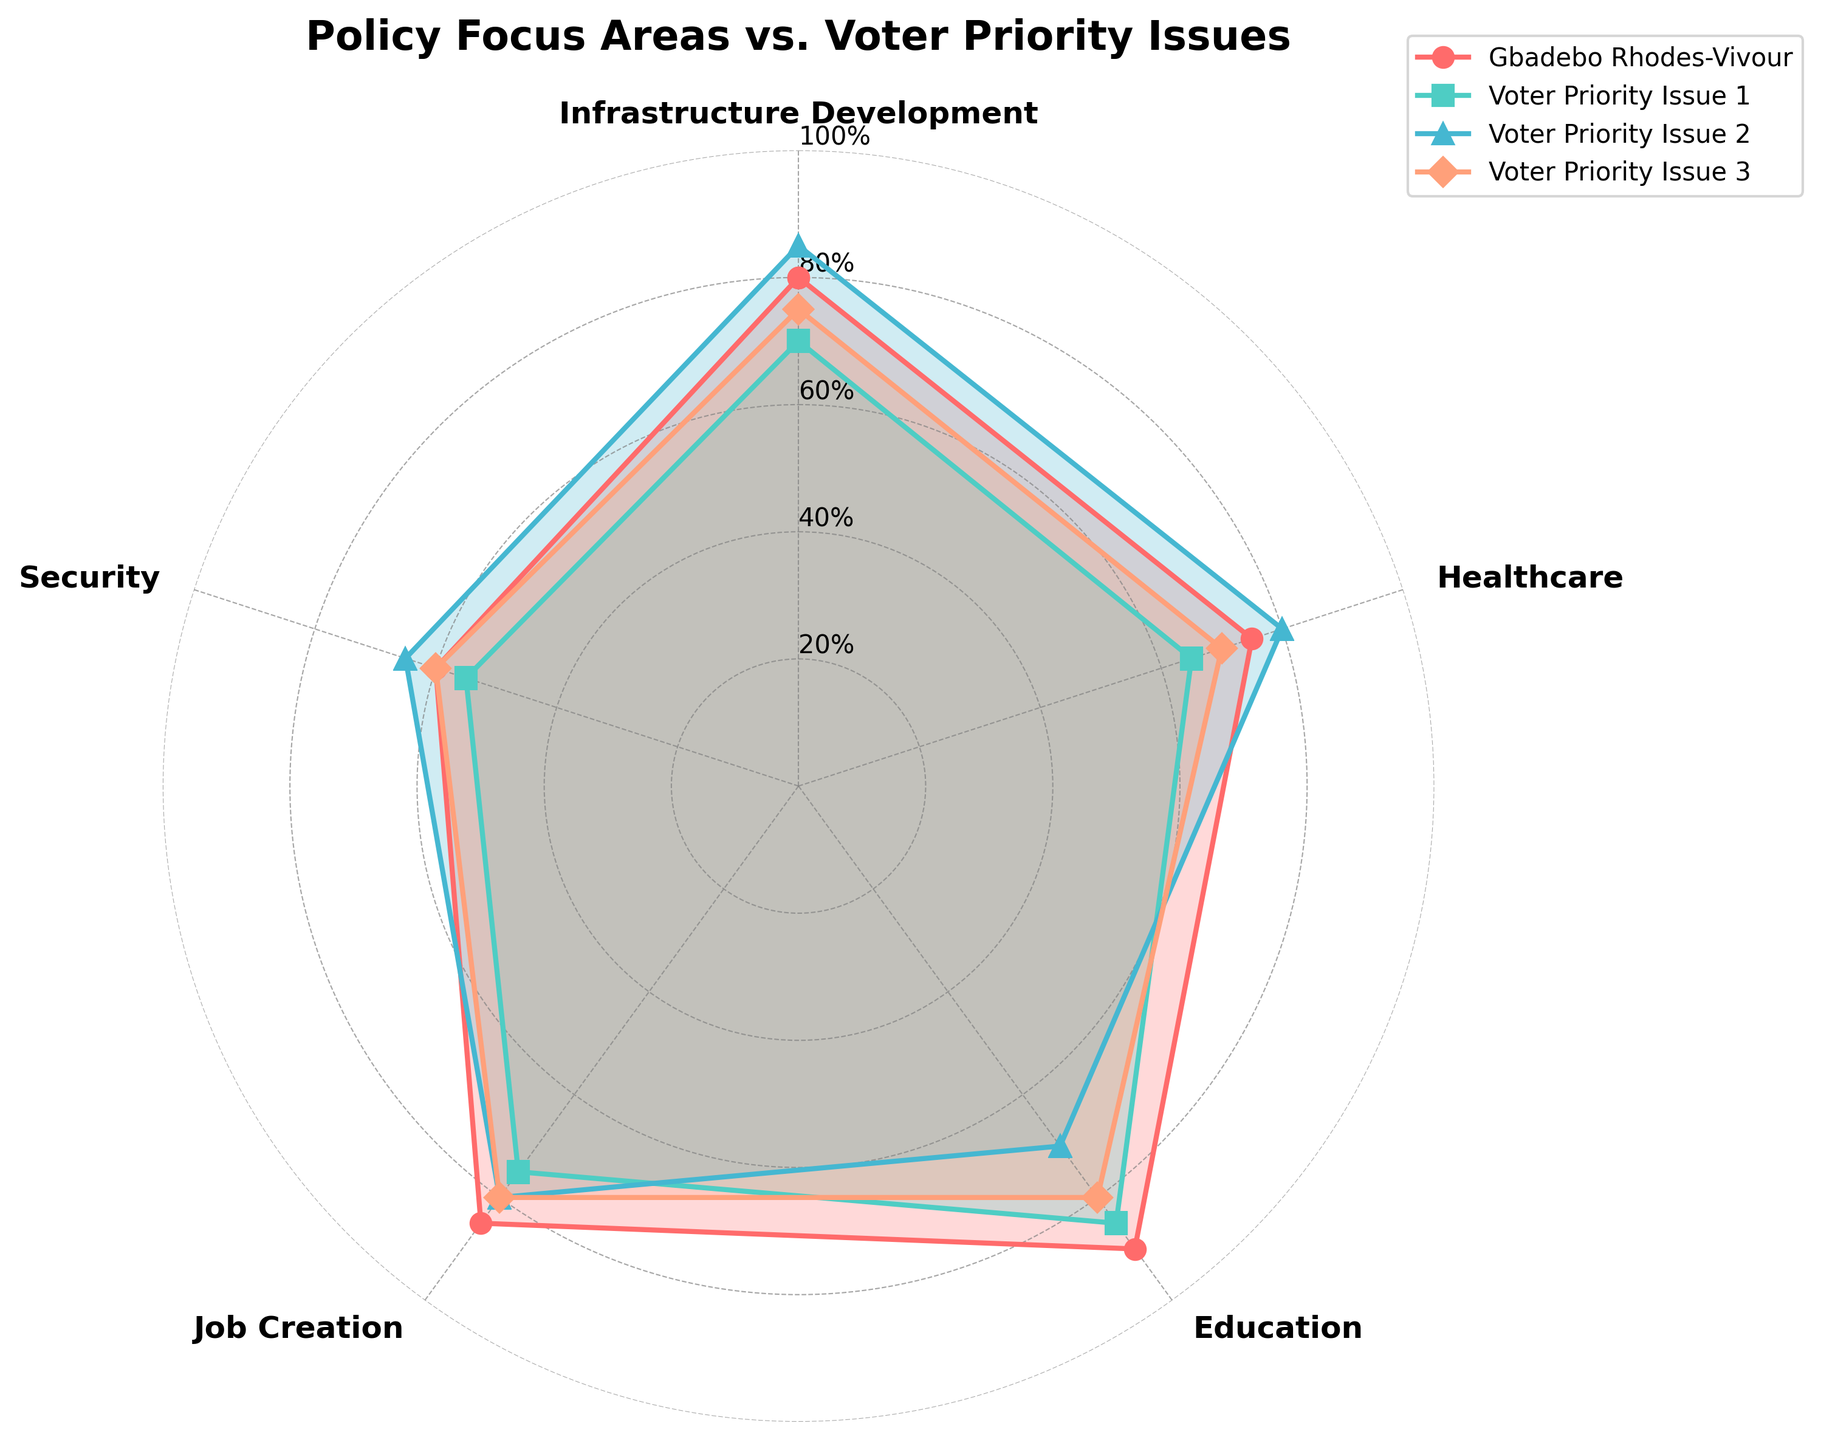What's the title of the figure? The title is usually at the top of the figure, and it provides an overview of what the chart represents. By looking directly at the top of the figure, we can read the title.
Answer: Policy Focus Areas vs. Voter Priority Issues Which policy focus area does Gbadebo Rhodes-Vivour prioritize the most? In the radar chart, Gbadebo Rhodes-Vivour's priorities are indicated by one of the colored lines. The highest value will represent the area of highest priority.
Answer: Education Which group has the highest value in the Security category? By comparing the values of the different colored lines at the Security point on the chart, we can see which group reaches the highest on the Security axis.
Answer: Voter Priority Issue 2 What is the difference in the Job Creation priority between Gbadebo Rhodes-Vivour and Voter Priority Issue 2? We need to locate the Job Creation points for both Gbadebo Rhodes-Vivour and Voter Priority Issue 2 on the chart and subtract the two values.
Answer: 5 What is the average priority score of Infrastructure Development for all Voter Priority Issues groups? To find the average, sum the values of Infrastructure Development for Voter Priority Issue 1, 2, and 3 and divide by the number of groups (3). Calculation: (70 + 85 + 75) / 3 = 76.67
Answer: 76.67% Which category has the smallest visual difference between Gbadebo Rhodes-Vivour and Voter Priority Issue 1? By visually inspecting the chart, we look for the smallest gap between the colored lines of Gbadebo Rhodes-Vivour and Voter Priority Issue 1 in different categories.
Answer: Security In which category does Voter Priority Issue 3 score exactly the same as Gbadebo Rhodes-Vivour? Check where the colored lines for both Gbadebo Rhodes-Vivour and Voter Priority Issue 3 meet at the same value in any of the categories.
Answer: Security Is there any category where Gbadebo Rhodes-Vivour has a lower score than all three Voter Priority Issues? We scan each category to see if Gbadebo Rhodes-Vivour's line is consistently below the other three voter issues group lines.
Answer: No What is the total of Gbadebo Rhodes-Vivour's priority scores across all categories? Sum all the values for Gbadebo Rhodes-Vivour's scores in each category. Calculation: 80 + 75 + 90 + 85 + 60 = 390
Answer: 390 Which group shows the most balanced emphasis across all categories? (least variance) Balance can be viewed as how evenly the values spread across different categories. We can visually assess which group's line is most circular/symmetrical.
Answer: Voter Priority Issue 3 